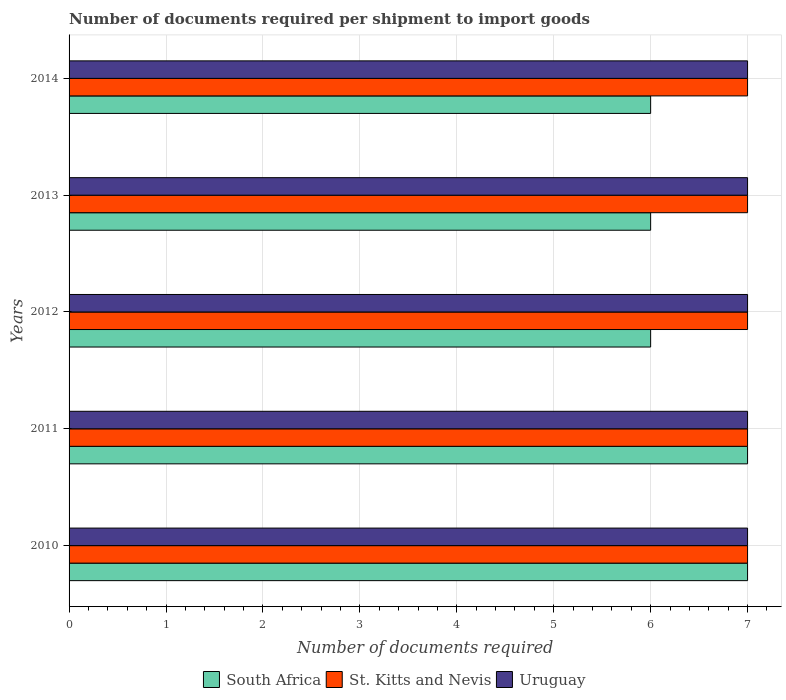How many different coloured bars are there?
Provide a succinct answer. 3. Are the number of bars per tick equal to the number of legend labels?
Offer a terse response. Yes. Are the number of bars on each tick of the Y-axis equal?
Your answer should be compact. Yes. How many bars are there on the 3rd tick from the top?
Offer a very short reply. 3. What is the label of the 2nd group of bars from the top?
Keep it short and to the point. 2013. What is the number of documents required per shipment to import goods in St. Kitts and Nevis in 2013?
Give a very brief answer. 7. Across all years, what is the maximum number of documents required per shipment to import goods in South Africa?
Provide a succinct answer. 7. Across all years, what is the minimum number of documents required per shipment to import goods in Uruguay?
Give a very brief answer. 7. What is the total number of documents required per shipment to import goods in Uruguay in the graph?
Provide a succinct answer. 35. What is the difference between the number of documents required per shipment to import goods in St. Kitts and Nevis in 2010 and that in 2013?
Provide a succinct answer. 0. What is the difference between the number of documents required per shipment to import goods in St. Kitts and Nevis in 2010 and the number of documents required per shipment to import goods in South Africa in 2013?
Offer a very short reply. 1. What is the average number of documents required per shipment to import goods in South Africa per year?
Your answer should be very brief. 6.4. In the year 2013, what is the difference between the number of documents required per shipment to import goods in South Africa and number of documents required per shipment to import goods in St. Kitts and Nevis?
Offer a very short reply. -1. In how many years, is the number of documents required per shipment to import goods in South Africa greater than 3.8 ?
Provide a short and direct response. 5. What is the ratio of the number of documents required per shipment to import goods in St. Kitts and Nevis in 2011 to that in 2012?
Your answer should be compact. 1. Is the number of documents required per shipment to import goods in South Africa in 2010 less than that in 2013?
Your response must be concise. No. Is the difference between the number of documents required per shipment to import goods in South Africa in 2011 and 2013 greater than the difference between the number of documents required per shipment to import goods in St. Kitts and Nevis in 2011 and 2013?
Provide a succinct answer. Yes. What is the difference between the highest and the lowest number of documents required per shipment to import goods in Uruguay?
Your answer should be compact. 0. In how many years, is the number of documents required per shipment to import goods in St. Kitts and Nevis greater than the average number of documents required per shipment to import goods in St. Kitts and Nevis taken over all years?
Offer a very short reply. 0. What does the 3rd bar from the top in 2011 represents?
Make the answer very short. South Africa. What does the 1st bar from the bottom in 2011 represents?
Your response must be concise. South Africa. Is it the case that in every year, the sum of the number of documents required per shipment to import goods in Uruguay and number of documents required per shipment to import goods in South Africa is greater than the number of documents required per shipment to import goods in St. Kitts and Nevis?
Offer a terse response. Yes. How many bars are there?
Offer a terse response. 15. Are all the bars in the graph horizontal?
Keep it short and to the point. Yes. What is the difference between two consecutive major ticks on the X-axis?
Ensure brevity in your answer.  1. Are the values on the major ticks of X-axis written in scientific E-notation?
Give a very brief answer. No. Does the graph contain any zero values?
Keep it short and to the point. No. How are the legend labels stacked?
Your answer should be compact. Horizontal. What is the title of the graph?
Provide a succinct answer. Number of documents required per shipment to import goods. What is the label or title of the X-axis?
Offer a terse response. Number of documents required. What is the Number of documents required in South Africa in 2011?
Make the answer very short. 7. What is the Number of documents required in St. Kitts and Nevis in 2011?
Ensure brevity in your answer.  7. What is the Number of documents required of South Africa in 2012?
Offer a terse response. 6. What is the Number of documents required in St. Kitts and Nevis in 2012?
Give a very brief answer. 7. What is the Number of documents required of South Africa in 2013?
Provide a succinct answer. 6. What is the Number of documents required of St. Kitts and Nevis in 2013?
Offer a terse response. 7. What is the Number of documents required of Uruguay in 2013?
Make the answer very short. 7. Across all years, what is the maximum Number of documents required in South Africa?
Your answer should be very brief. 7. Across all years, what is the maximum Number of documents required in Uruguay?
Your answer should be very brief. 7. Across all years, what is the minimum Number of documents required of South Africa?
Your answer should be compact. 6. Across all years, what is the minimum Number of documents required of St. Kitts and Nevis?
Your response must be concise. 7. What is the total Number of documents required in South Africa in the graph?
Your answer should be compact. 32. What is the total Number of documents required of St. Kitts and Nevis in the graph?
Your answer should be compact. 35. What is the difference between the Number of documents required in South Africa in 2010 and that in 2011?
Provide a succinct answer. 0. What is the difference between the Number of documents required of South Africa in 2010 and that in 2012?
Your response must be concise. 1. What is the difference between the Number of documents required in Uruguay in 2010 and that in 2012?
Give a very brief answer. 0. What is the difference between the Number of documents required of South Africa in 2010 and that in 2013?
Provide a short and direct response. 1. What is the difference between the Number of documents required of St. Kitts and Nevis in 2010 and that in 2013?
Provide a short and direct response. 0. What is the difference between the Number of documents required in Uruguay in 2010 and that in 2013?
Your response must be concise. 0. What is the difference between the Number of documents required of Uruguay in 2010 and that in 2014?
Give a very brief answer. 0. What is the difference between the Number of documents required of St. Kitts and Nevis in 2011 and that in 2012?
Make the answer very short. 0. What is the difference between the Number of documents required of Uruguay in 2011 and that in 2012?
Provide a succinct answer. 0. What is the difference between the Number of documents required of St. Kitts and Nevis in 2011 and that in 2013?
Offer a terse response. 0. What is the difference between the Number of documents required in Uruguay in 2011 and that in 2013?
Ensure brevity in your answer.  0. What is the difference between the Number of documents required in South Africa in 2011 and that in 2014?
Your answer should be compact. 1. What is the difference between the Number of documents required in St. Kitts and Nevis in 2011 and that in 2014?
Provide a succinct answer. 0. What is the difference between the Number of documents required in South Africa in 2012 and that in 2014?
Your answer should be compact. 0. What is the difference between the Number of documents required of St. Kitts and Nevis in 2012 and that in 2014?
Keep it short and to the point. 0. What is the difference between the Number of documents required in South Africa in 2010 and the Number of documents required in St. Kitts and Nevis in 2011?
Provide a short and direct response. 0. What is the difference between the Number of documents required of South Africa in 2010 and the Number of documents required of Uruguay in 2011?
Offer a terse response. 0. What is the difference between the Number of documents required of St. Kitts and Nevis in 2010 and the Number of documents required of Uruguay in 2011?
Keep it short and to the point. 0. What is the difference between the Number of documents required of St. Kitts and Nevis in 2010 and the Number of documents required of Uruguay in 2013?
Your answer should be compact. 0. What is the difference between the Number of documents required in St. Kitts and Nevis in 2010 and the Number of documents required in Uruguay in 2014?
Provide a short and direct response. 0. What is the difference between the Number of documents required in St. Kitts and Nevis in 2011 and the Number of documents required in Uruguay in 2012?
Offer a very short reply. 0. What is the difference between the Number of documents required of South Africa in 2011 and the Number of documents required of St. Kitts and Nevis in 2013?
Ensure brevity in your answer.  0. What is the difference between the Number of documents required in South Africa in 2012 and the Number of documents required in Uruguay in 2013?
Your answer should be compact. -1. What is the difference between the Number of documents required in South Africa in 2012 and the Number of documents required in Uruguay in 2014?
Offer a terse response. -1. In the year 2010, what is the difference between the Number of documents required in South Africa and Number of documents required in St. Kitts and Nevis?
Your answer should be very brief. 0. In the year 2011, what is the difference between the Number of documents required in South Africa and Number of documents required in St. Kitts and Nevis?
Keep it short and to the point. 0. In the year 2011, what is the difference between the Number of documents required of South Africa and Number of documents required of Uruguay?
Keep it short and to the point. 0. In the year 2012, what is the difference between the Number of documents required of South Africa and Number of documents required of Uruguay?
Provide a short and direct response. -1. In the year 2012, what is the difference between the Number of documents required of St. Kitts and Nevis and Number of documents required of Uruguay?
Offer a very short reply. 0. In the year 2013, what is the difference between the Number of documents required in South Africa and Number of documents required in Uruguay?
Make the answer very short. -1. In the year 2013, what is the difference between the Number of documents required of St. Kitts and Nevis and Number of documents required of Uruguay?
Give a very brief answer. 0. What is the ratio of the Number of documents required of South Africa in 2010 to that in 2011?
Your answer should be very brief. 1. What is the ratio of the Number of documents required of St. Kitts and Nevis in 2010 to that in 2011?
Make the answer very short. 1. What is the ratio of the Number of documents required in South Africa in 2010 to that in 2012?
Ensure brevity in your answer.  1.17. What is the ratio of the Number of documents required of St. Kitts and Nevis in 2010 to that in 2012?
Provide a short and direct response. 1. What is the ratio of the Number of documents required of South Africa in 2010 to that in 2013?
Your answer should be compact. 1.17. What is the ratio of the Number of documents required of Uruguay in 2010 to that in 2014?
Your answer should be compact. 1. What is the ratio of the Number of documents required in St. Kitts and Nevis in 2011 to that in 2012?
Keep it short and to the point. 1. What is the ratio of the Number of documents required in South Africa in 2011 to that in 2013?
Keep it short and to the point. 1.17. What is the ratio of the Number of documents required in Uruguay in 2011 to that in 2013?
Your answer should be compact. 1. What is the ratio of the Number of documents required of St. Kitts and Nevis in 2011 to that in 2014?
Your answer should be very brief. 1. What is the ratio of the Number of documents required of South Africa in 2012 to that in 2013?
Give a very brief answer. 1. What is the ratio of the Number of documents required in St. Kitts and Nevis in 2012 to that in 2013?
Give a very brief answer. 1. What is the difference between the highest and the second highest Number of documents required in St. Kitts and Nevis?
Provide a short and direct response. 0. What is the difference between the highest and the lowest Number of documents required of St. Kitts and Nevis?
Make the answer very short. 0. 